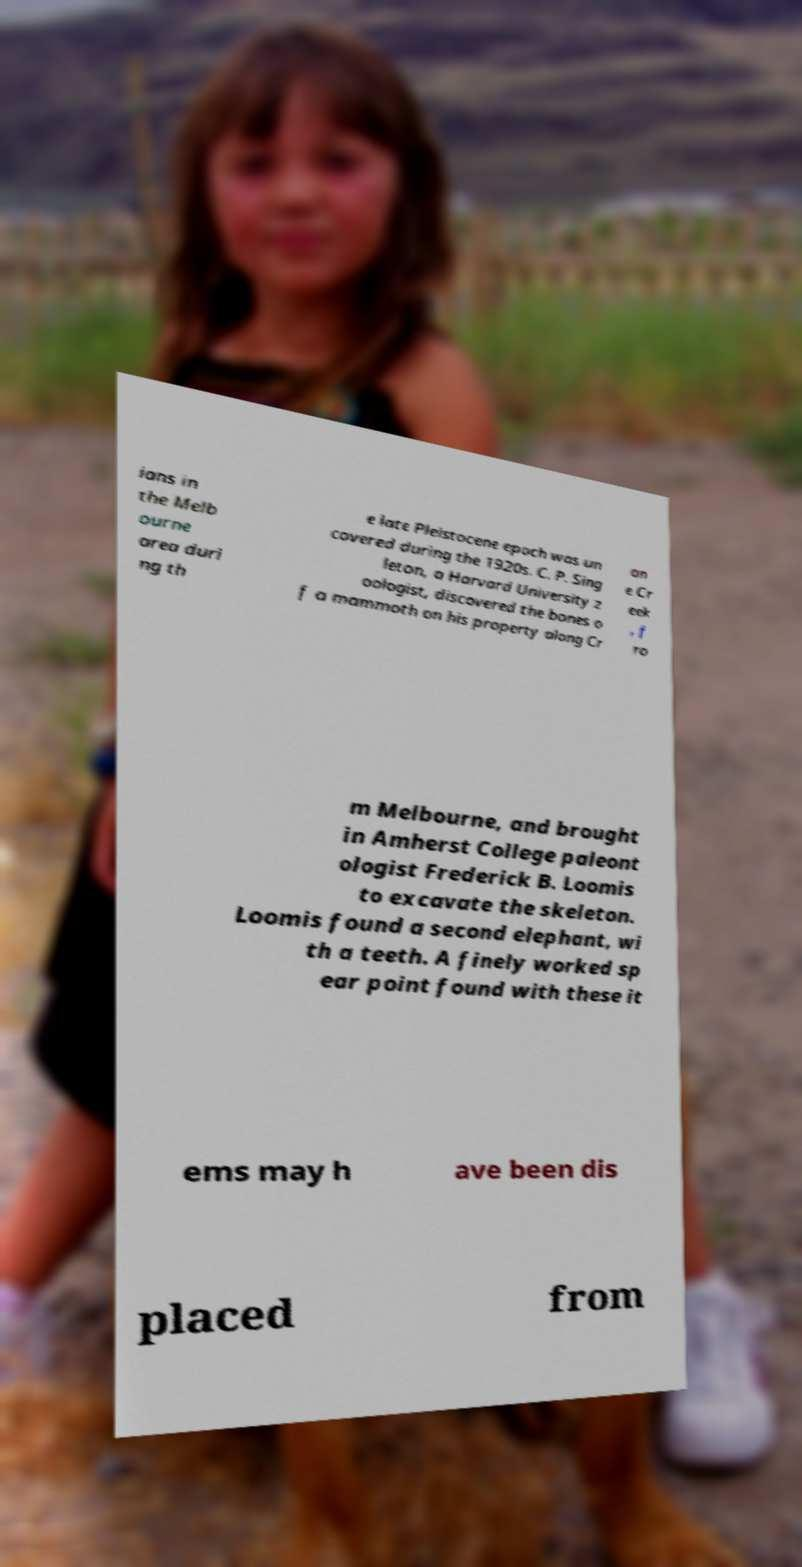What messages or text are displayed in this image? I need them in a readable, typed format. ians in the Melb ourne area duri ng th e late Pleistocene epoch was un covered during the 1920s. C. P. Sing leton, a Harvard University z oologist, discovered the bones o f a mammoth on his property along Cr an e Cr eek , f ro m Melbourne, and brought in Amherst College paleont ologist Frederick B. Loomis to excavate the skeleton. Loomis found a second elephant, wi th a teeth. A finely worked sp ear point found with these it ems may h ave been dis placed from 